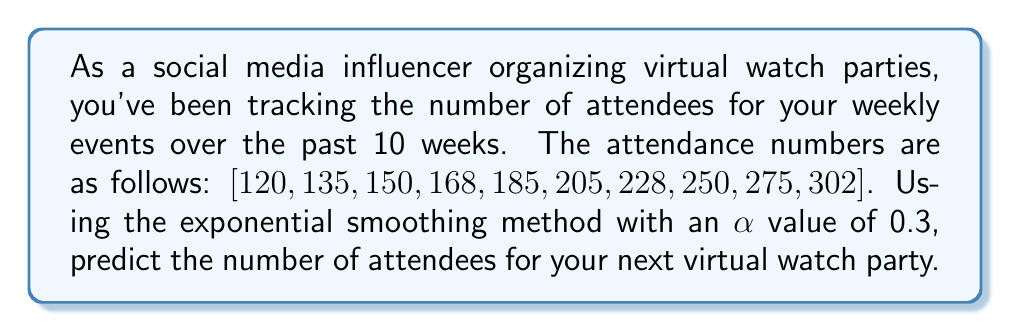Can you answer this question? To solve this problem, we'll use the exponential smoothing method, which is a time series forecasting technique. The formula for exponential smoothing is:

$$F_{t+1} = \alpha Y_t + (1-\alpha)F_t$$

Where:
$F_{t+1}$ is the forecast for the next period
$\alpha$ is the smoothing factor (given as 0.3)
$Y_t$ is the actual value at time t
$F_t$ is the forecast for the current period

Let's calculate the forecast step by step:

1. Initialize $F_1$ with the first actual value: $F_1 = 120$

2. Calculate subsequent forecasts:
   $F_2 = 0.3(120) + 0.7(120) = 120$
   $F_3 = 0.3(135) + 0.7(120) = 124.5$
   $F_4 = 0.3(150) + 0.7(124.5) = 132.15$
   $F_5 = 0.3(168) + 0.7(132.15) = 142.905$
   $F_6 = 0.3(185) + 0.7(142.905) = 155.5335$
   $F_7 = 0.3(205) + 0.7(155.5335) = 170.87345$
   $F_8 = 0.3(228) + 0.7(170.87345) = 188.31142$
   $F_9 = 0.3(250) + 0.7(188.31142) = 206.81799$
   $F_{10} = 0.3(275) + 0.7(206.81799) = 227.07259$

3. Calculate the forecast for the next period (week 11):
   $F_{11} = 0.3(302) + 0.7(227.07259) = 249.55081$

Rounding to the nearest whole number, we get 250 attendees for the next virtual watch party.
Answer: 250 attendees 